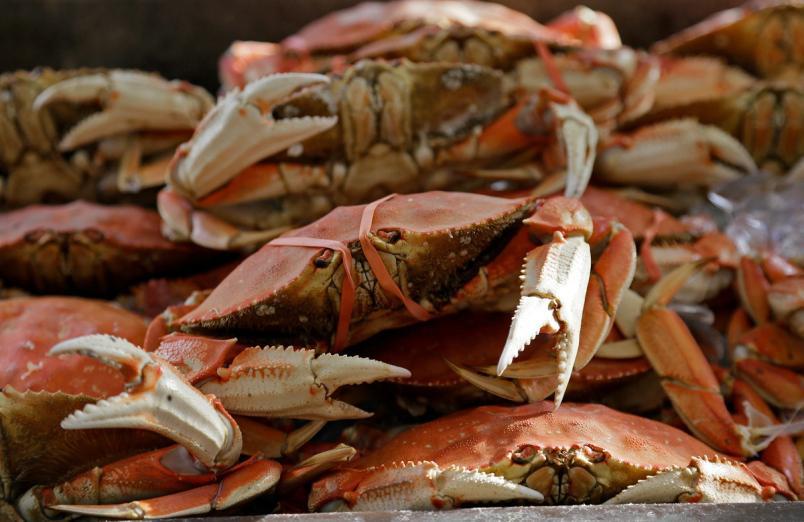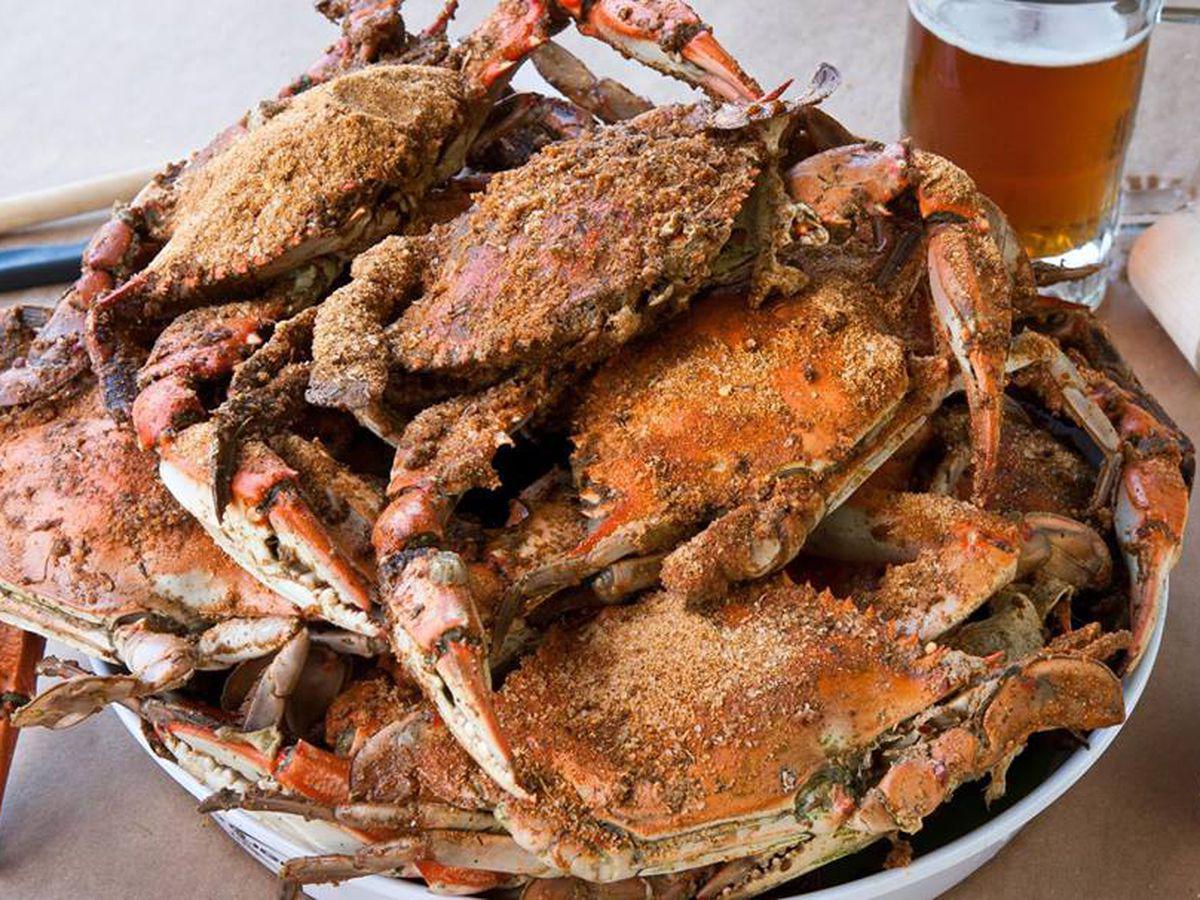The first image is the image on the left, the second image is the image on the right. Considering the images on both sides, is "At least one beverage in a clear glass is on the right of a pile of seafood with claws in one image." valid? Answer yes or no. Yes. 